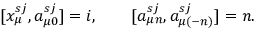Convert formula to latex. <formula><loc_0><loc_0><loc_500><loc_500>[ x _ { \mu } ^ { s j } , a _ { \mu 0 } ^ { s j } ] = i , \quad [ a _ { \mu n } ^ { s j } , a _ { \mu ( - n ) } ^ { s j } ] = n .</formula> 